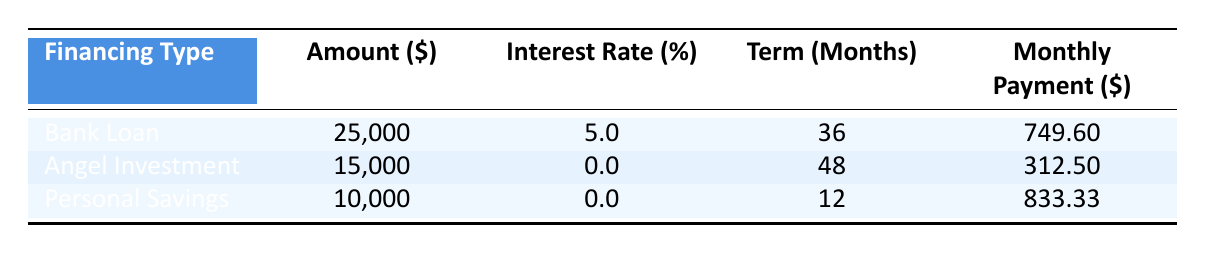What is the total cost of financing custom souvenirs? The total cost is provided in the financing breakdown section of the table, which shows a total cost of 50,000.
Answer: 50,000 How much is the monthly payment for the bank loan? The monthly payment for the bank loan can be found under the "Monthly Payment" column for the "Bank Loan" row, which states it is 749.60.
Answer: 749.60 What is the interest rate for the angel investment? The interest rate for the angel investment is listed in the "Interest Rate (%)" column for the "Angel Investment" row, which shows it to be 0.0.
Answer: 0.0 Which financing option has the longest term? To find the longest term, we compare the "Term (Months)" values for each financing option: the bank loan is 36 months, the angel investment is 48 months, and personal savings is 12 months. The angel investment has the longest term at 48 months.
Answer: Angel Investment What is the total amount financed through personal savings and angel investment combined? The amounts for personal savings and angel investment are 10,000 and 15,000, respectively. We sum these amounts: 10,000 + 15,000 = 25,000.
Answer: 25,000 Is the interest rate for the bank loan higher than that for personal savings? The interest rate for the bank loan is 5.0%, and for personal savings, it is 0.0%. Since 5.0% is greater than 0.0%, the statement is true.
Answer: Yes What is the average monthly payment of all financing options? First, we calculate the total monthly payments: 749.60 (bank loan) + 312.50 (angel investment) + 833.33 (personal savings) = 1,895.43. Next, we divide this total by the number of financing options, which is 3: 1,895.43 / 3 ≈ 631.81.
Answer: 631.81 How much more is the labor cost compared to the marketing cost? The labor cost is 15,000, and the marketing cost is 5,000. We find the difference by subtracting the marketing cost from the labor cost: 15,000 - 5,000 = 10,000.
Answer: 10,000 Can the total cost of materials cover both the labor and marketing costs combined? The total cost of materials is 20,000. The combined costs of labor (15,000) and marketing (5,000) total 20,000 as well. Since 20,000 equals 20,000, the answer is yes.
Answer: Yes 